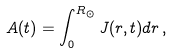<formula> <loc_0><loc_0><loc_500><loc_500>A ( t ) = \int ^ { R _ { \odot } } _ { 0 } J ( r , t ) d r \, ,</formula> 